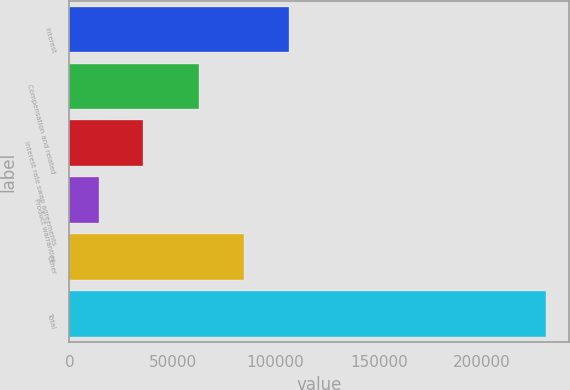Convert chart to OTSL. <chart><loc_0><loc_0><loc_500><loc_500><bar_chart><fcel>Interest<fcel>Compensation and related<fcel>Interest rate swap agreements<fcel>Product warranties<fcel>Other<fcel>Total<nl><fcel>106383<fcel>63057<fcel>35905.8<fcel>14243<fcel>84719.8<fcel>230871<nl></chart> 